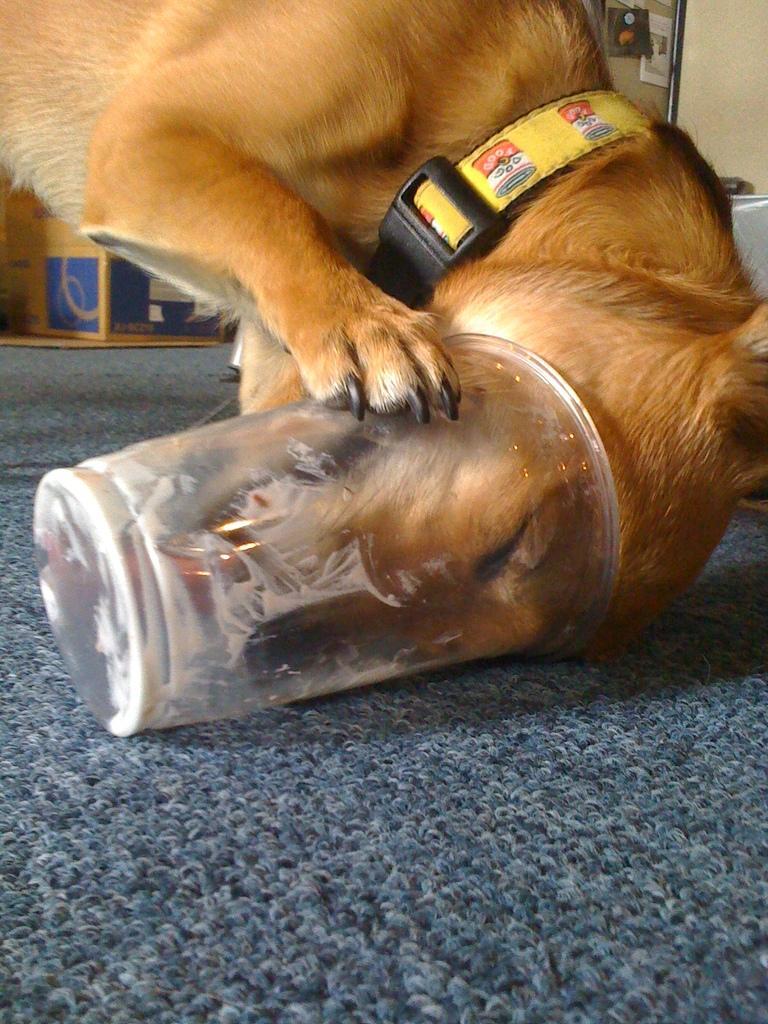Describe this image in one or two sentences. In this image we can see the dog standing on the mat and we can see the dog face in the object. And we can see boxes and few objects in the background. 